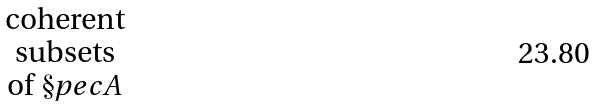<formula> <loc_0><loc_0><loc_500><loc_500>\begin{matrix} \text {coherent} \\ \text {subsets} \\ \text {of } \S p e c A \end{matrix}</formula> 